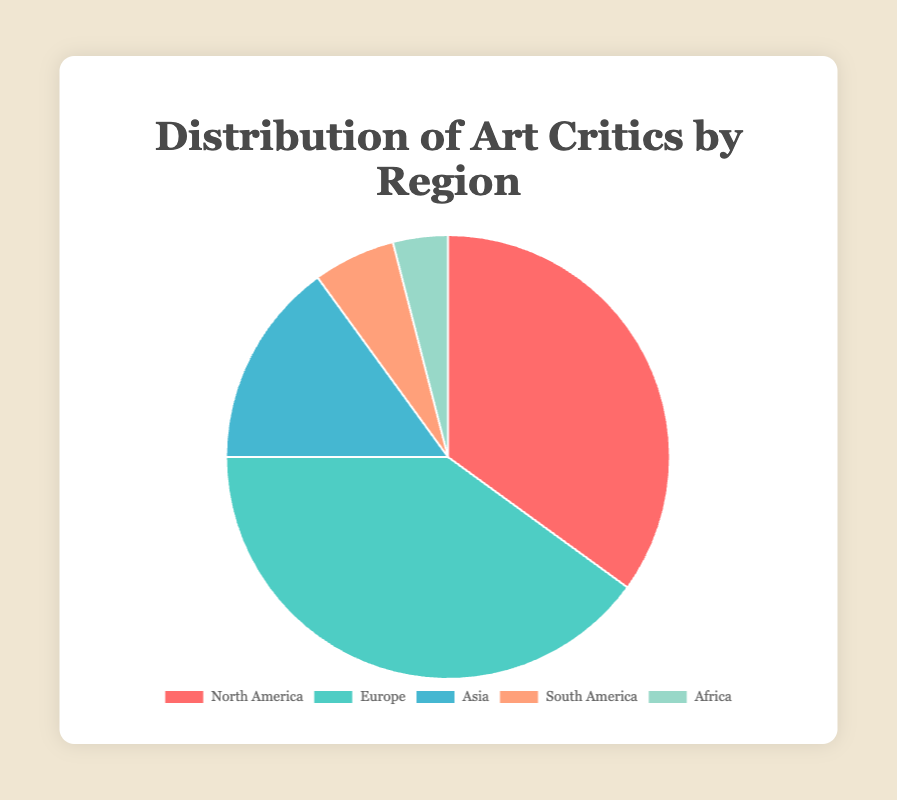What percentage of art critics are from Europe? First, identify the number of art critics from Europe, which is 40. Next, sum the total number of art critics: 35 (North America) + 40 (Europe) + 15 (Asia) + 6 (South America) + 4 (Africa) = 100. The percentage is then calculated as (40 / 100) * 100 = 40%.
Answer: 40% How does the number of art critics in North America compare to those in Asia? The number of art critics in North America is 35, while in Asia it is 15. To compare, subtract the number in Asia from North America: 35 - 15 = 20. This shows that North America has 20 more art critics than Asia.
Answer: North America has 20 more Which region has the smallest representation of art critics? Look at the data points: North America (35), Europe (40), Asia (15), South America (6), and Africa (4). The smallest value is 4, which corresponds to Africa.
Answer: Africa What is the total number of art critics in South America and Africa combined? The number of art critics in South America is 6, and in Africa, it is 4. Add these two numbers together: 6 + 4 = 10.
Answer: 10 What is the difference between the region with the most and the region with the fewest art critics? Identify the region with the most art critics (Europe, 40) and the region with the fewest art critics (Africa, 4). Subtract the smallest value from the largest: 40 - 4 = 36.
Answer: 36 If you combined the art critics from North America and Asia, what percentage of the total would that be? First, find the number of art critics from North America (35) and Asia (15). Sum these to get 50. The total number of art critics is 100. Calculate the percentage: (50 / 100) * 100 = 50%.
Answer: 50% Which region's slice of the pie chart is depicted in green? From the description of colors: the slice for North America is red, Europe is aqua, Asia is light blue, South America is orange, and Africa is green. Therefore, Africa's slice is green.
Answer: Africa What is the average number of art critics per region? Add the number of art critics for all regions: 35 (North America) + 40 (Europe) + 15 (Asia) + 6 (South America) + 4 (Africa) = 100. Then, divide by the number of regions (5): 100 / 5 = 20.
Answer: 20 How many more art critics are there in North America and Europe combined than in South America and Africa combined? First, find the total for North America and Europe: 35 + 40 = 75. Then, find the total for South America and Africa: 6 + 4 = 10. Subtract the smaller total from the larger: 75 - 10 = 65.
Answer: 65 What two regions have a combined total of 21 art critics? Look at the data points: North America (35), Europe (40), Asia (15), South America (6), and Africa (4). Try different combinations to find the pair that sums to 21. Asia (15) and South America (6) add up to 21.
Answer: Asia and South America 